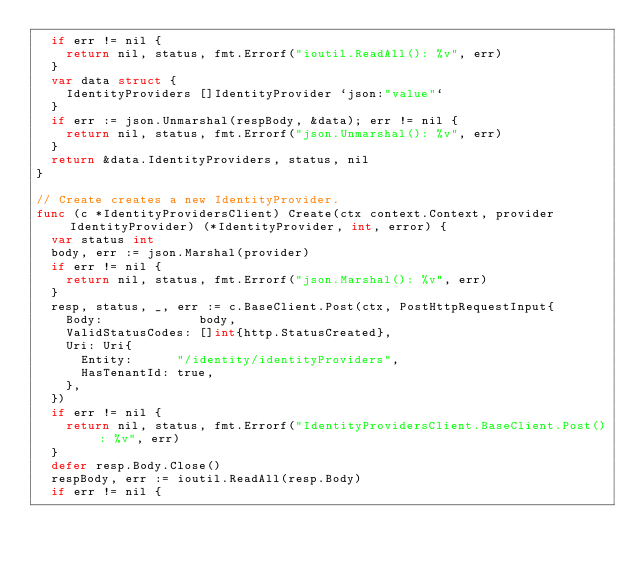Convert code to text. <code><loc_0><loc_0><loc_500><loc_500><_Go_>	if err != nil {
		return nil, status, fmt.Errorf("ioutil.ReadAll(): %v", err)
	}
	var data struct {
		IdentityProviders []IdentityProvider `json:"value"`
	}
	if err := json.Unmarshal(respBody, &data); err != nil {
		return nil, status, fmt.Errorf("json.Unmarshal(): %v", err)
	}
	return &data.IdentityProviders, status, nil
}

// Create creates a new IdentityProvider.
func (c *IdentityProvidersClient) Create(ctx context.Context, provider IdentityProvider) (*IdentityProvider, int, error) {
	var status int
	body, err := json.Marshal(provider)
	if err != nil {
		return nil, status, fmt.Errorf("json.Marshal(): %v", err)
	}
	resp, status, _, err := c.BaseClient.Post(ctx, PostHttpRequestInput{
		Body:             body,
		ValidStatusCodes: []int{http.StatusCreated},
		Uri: Uri{
			Entity:      "/identity/identityProviders",
			HasTenantId: true,
		},
	})
	if err != nil {
		return nil, status, fmt.Errorf("IdentityProvidersClient.BaseClient.Post(): %v", err)
	}
	defer resp.Body.Close()
	respBody, err := ioutil.ReadAll(resp.Body)
	if err != nil {</code> 